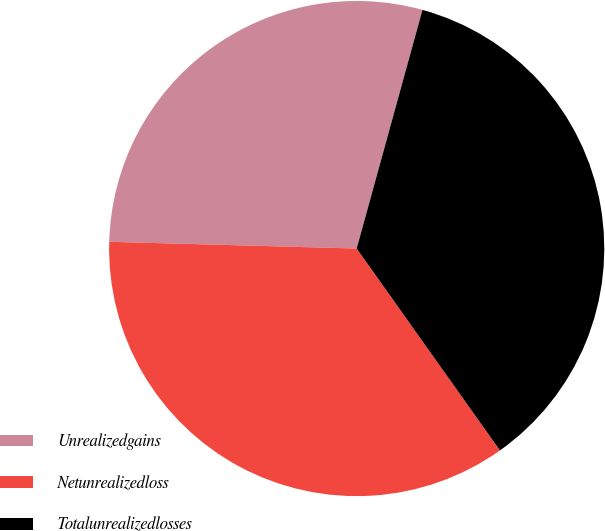<chart> <loc_0><loc_0><loc_500><loc_500><pie_chart><fcel>Unrealizedgains<fcel>Netunrealizedloss<fcel>Totalunrealizedlosses<nl><fcel>28.85%<fcel>35.26%<fcel>35.9%<nl></chart> 